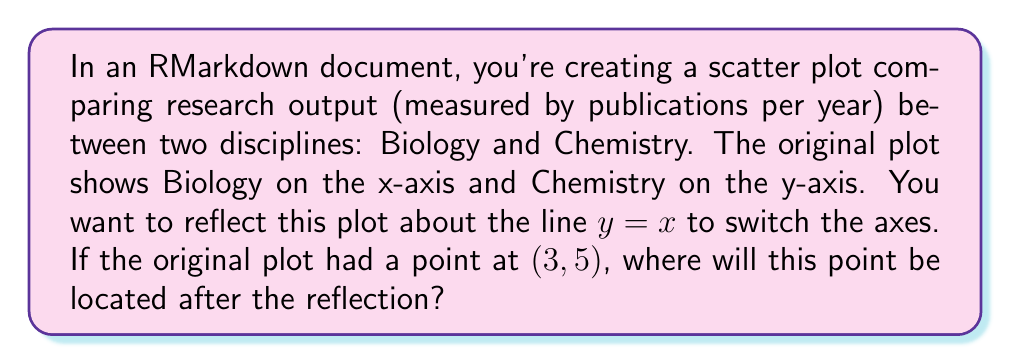Solve this math problem. To solve this problem, we need to understand the concept of reflection about the line $y = x$. Here's a step-by-step explanation:

1) The line $y = x$ is the diagonal line that passes through the origin and has a slope of 1. It bisects the first and third quadrants.

2) Reflection about $y = x$ essentially swaps the x and y coordinates of each point.

3) Mathematically, if we have a point $(a, b)$, its reflection about $y = x$ will be $(b, a)$.

4) In this case, our original point is $(3, 5)$.

5) To reflect this point, we simply swap the coordinates:
   $(3, 5)$ becomes $(5, 3)$

6) In the context of the plot, this means that a data point representing 3 publications per year in Biology and 5 in Chemistry will, after reflection, represent 5 publications per year in Biology and 3 in Chemistry.

This reflection effectively switches the axes of the plot, so Biology will now be on the y-axis and Chemistry on the x-axis.
Answer: $(5, 3)$ 